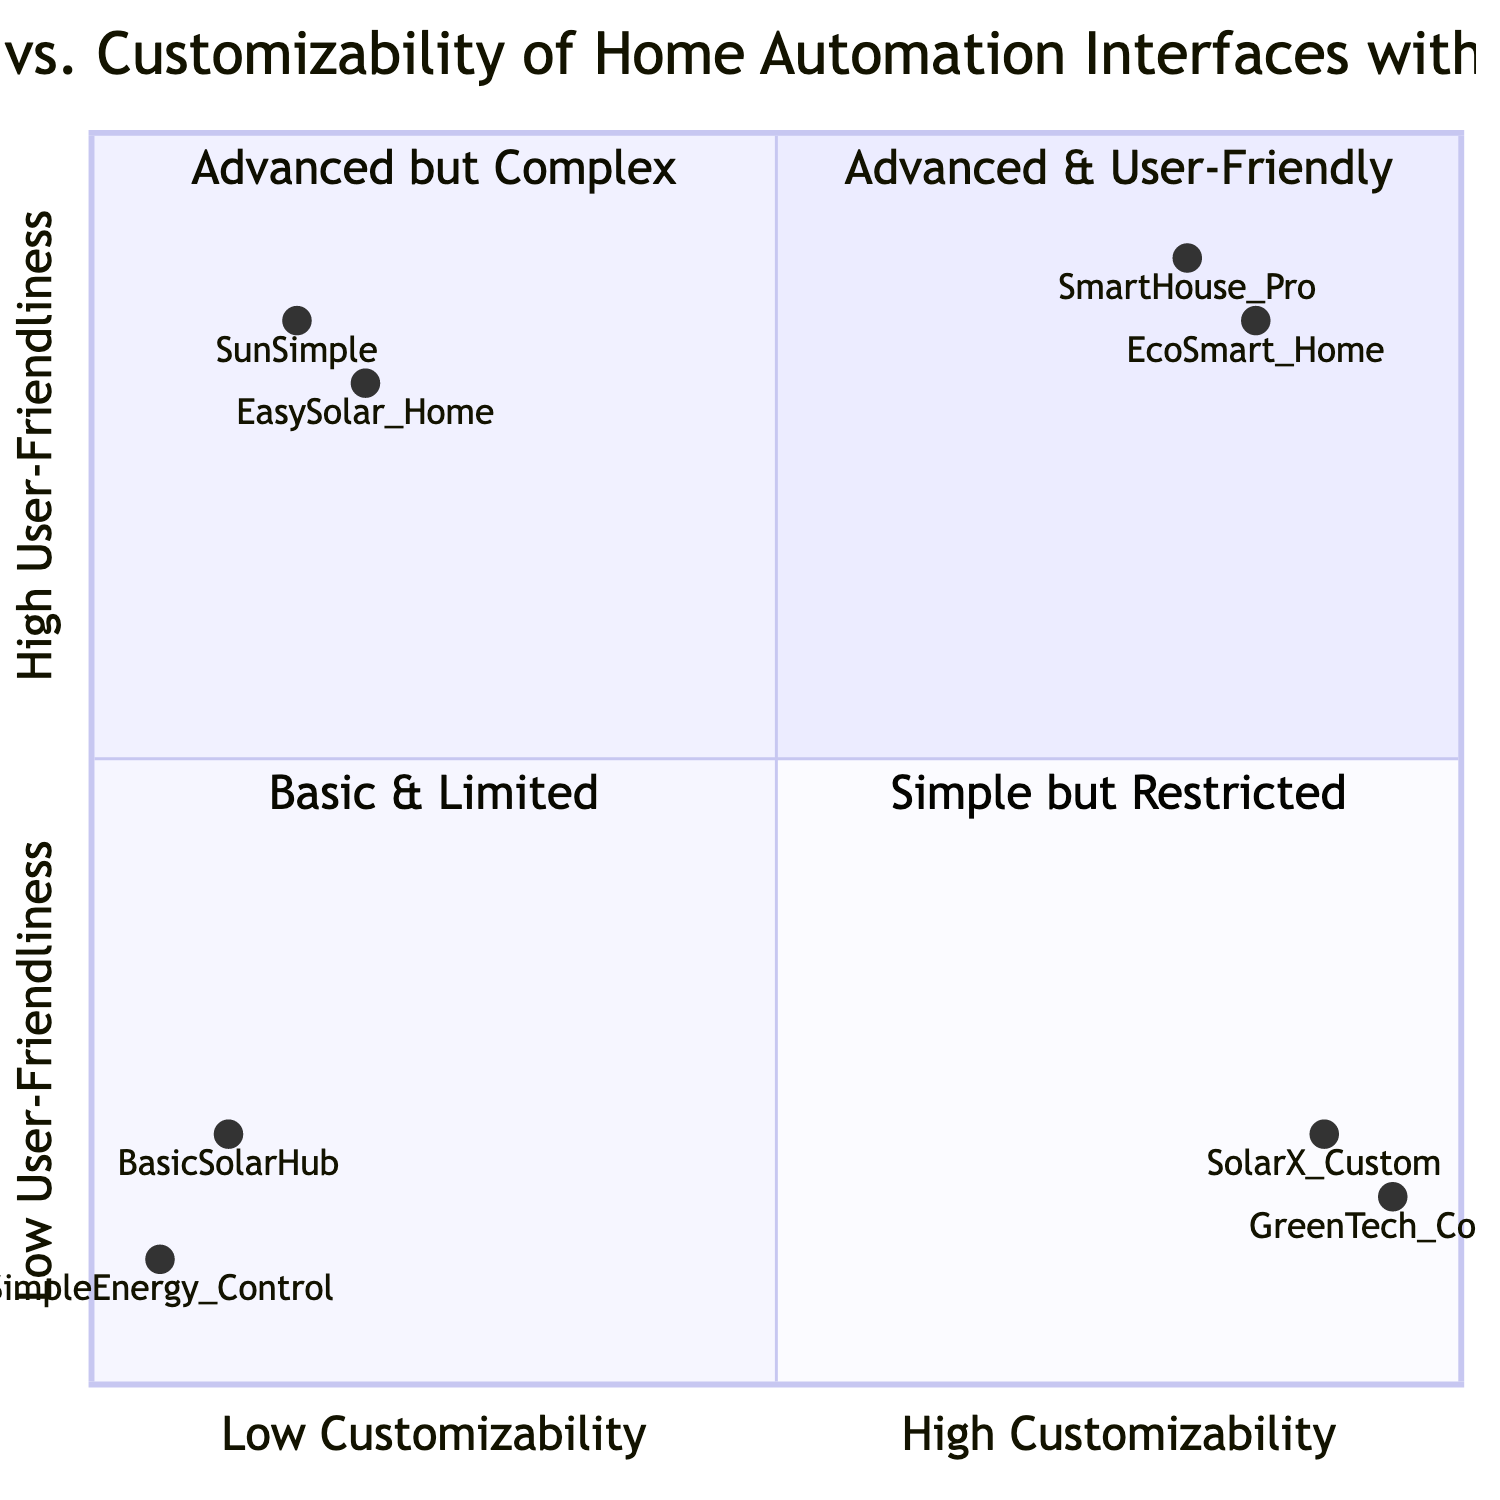What are the two products located in the high customizability high user-friendly quadrant? The products in this quadrant are SmartHouse Pro and EcoSmart Home as indicated by their coordinates in quadrant 1 of the diagram.
Answer: SmartHouse Pro, EcoSmart Home Which product has the highest user-friendliness score? By analyzing the y-coordinate values in the diagram, EcoSmart Home has the highest y-value of 0.85, indicating it has the highest user-friendliness score.
Answer: EcoSmart Home How many products are located in the low customizability low user-friendly quadrant? The products positioned in quadrant 4 of the diagram are BasicSolarHub and SimpleEnergy Control, making a total of two products in this category.
Answer: 2 Which product shows the most advanced customization options but low user-friendliness? SolarX Custom is in the quadrant with high customizability and low user-friendliness, indicated by its coordinates in quadrant 2.
Answer: SolarX Custom What is the average user-friendliness score of the products in the low customizability high user-friendly quadrant? The products EasySolar Home and SunSimple have y-values of 0.8 and 0.85, respectively. The average is calculated as (0.8 + 0.85) / 2 = 0.825.
Answer: 0.825 Which two products have limited customization options? The products BasicSolarHub and SimpleEnergy Control fall under low customizability, as shown in quadrant 4 of the diagram.
Answer: BasicSolarHub, SimpleEnergy Control How do the features of SolarX Custom compare to those of EcoSmart Home? Comparing the features, SolarX Custom offers modular design and complex rule creation, while EcoSmart Home features an intuitive app design and custom automation scripts. This shows that both products target different user needs.
Answer: Different focus What is the minimum score for user-friendliness among all products? By checking the y-values on the diagram, SimpleEnergy Control has the lowest score of 0.1 in user-friendliness, indicating the minimum score observed across all products.
Answer: 0.1 In which quadrant is the product SunSimple located? SunSimple's coordinates indicate it is within quadrant 1, which is high user-friendliness but low customizability, as per its placement in the diagram.
Answer: Quadrant 1 